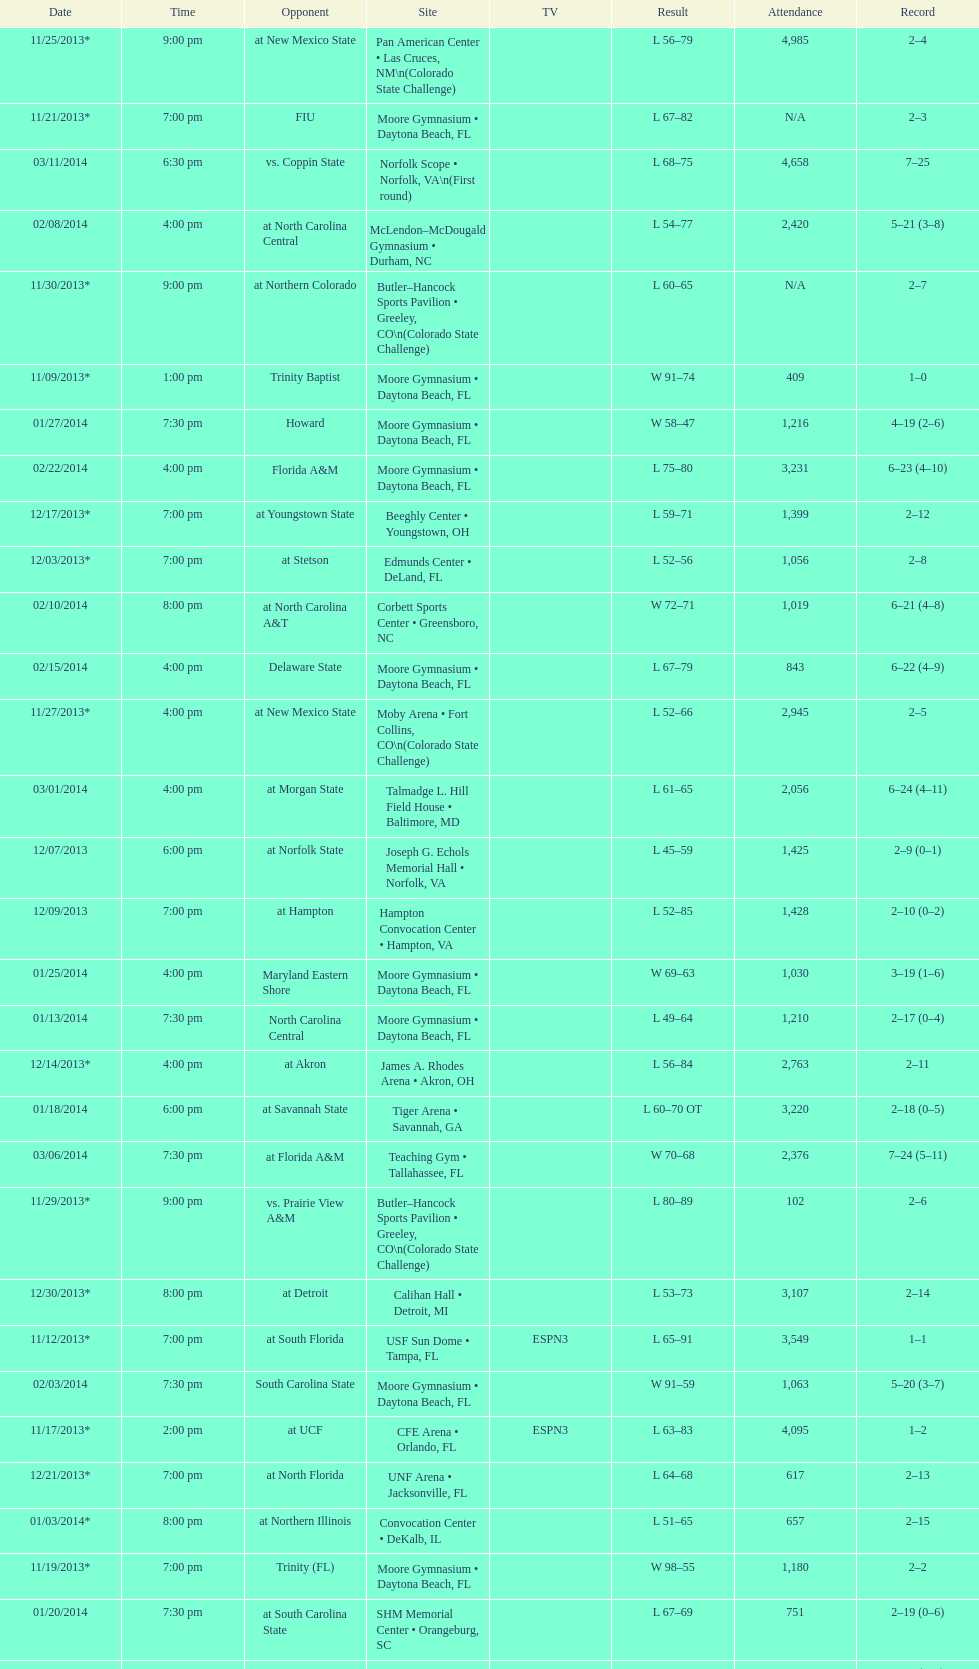Was the attendance of the game held on 11/19/2013 greater than 1,000? Yes. 